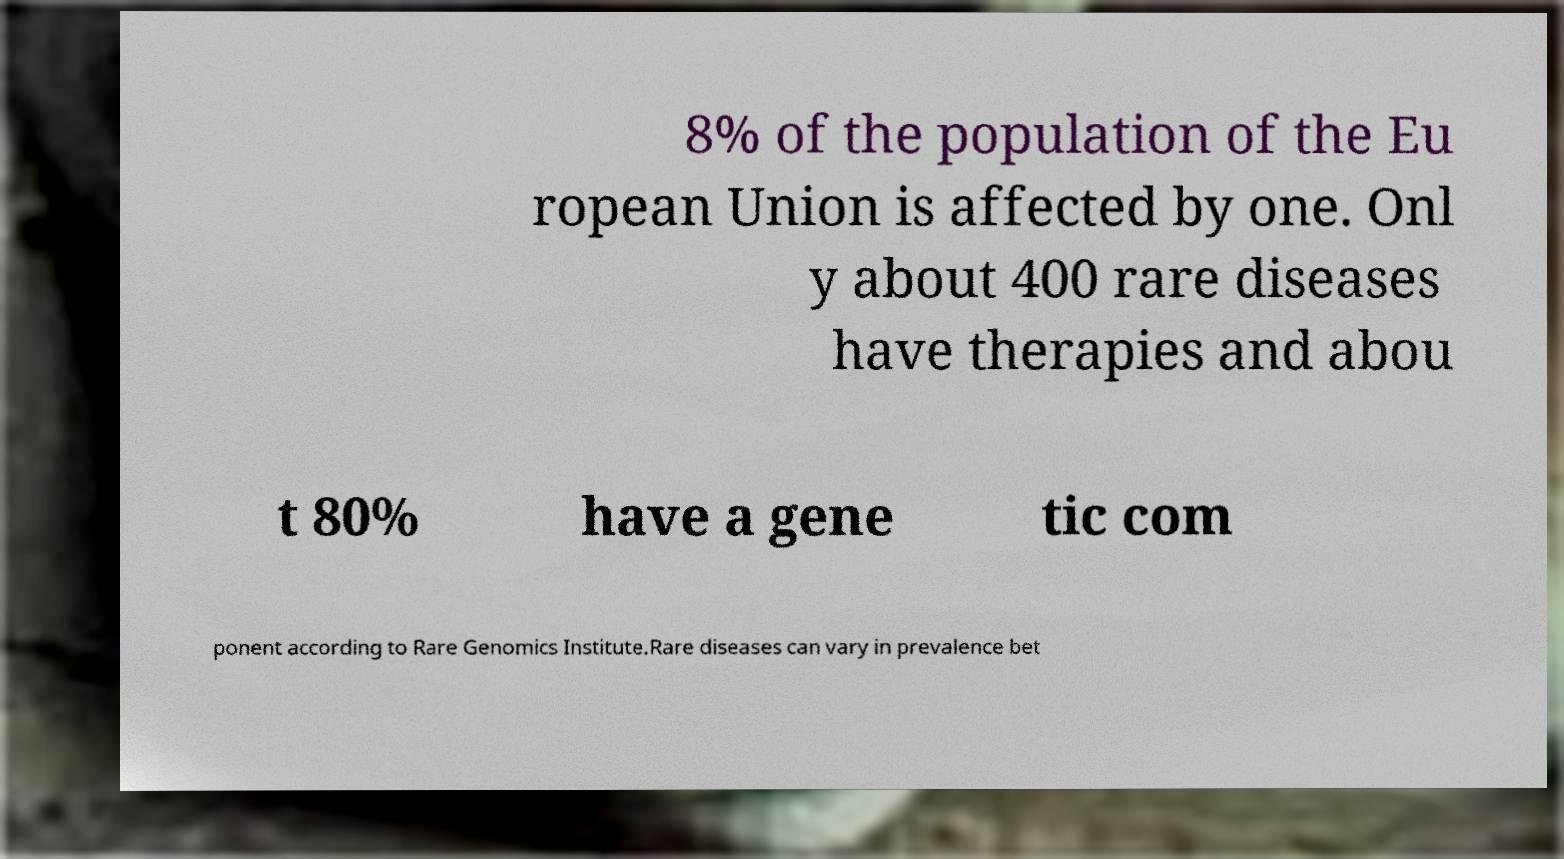Can you accurately transcribe the text from the provided image for me? 8% of the population of the Eu ropean Union is affected by one. Onl y about 400 rare diseases have therapies and abou t 80% have a gene tic com ponent according to Rare Genomics Institute.Rare diseases can vary in prevalence bet 